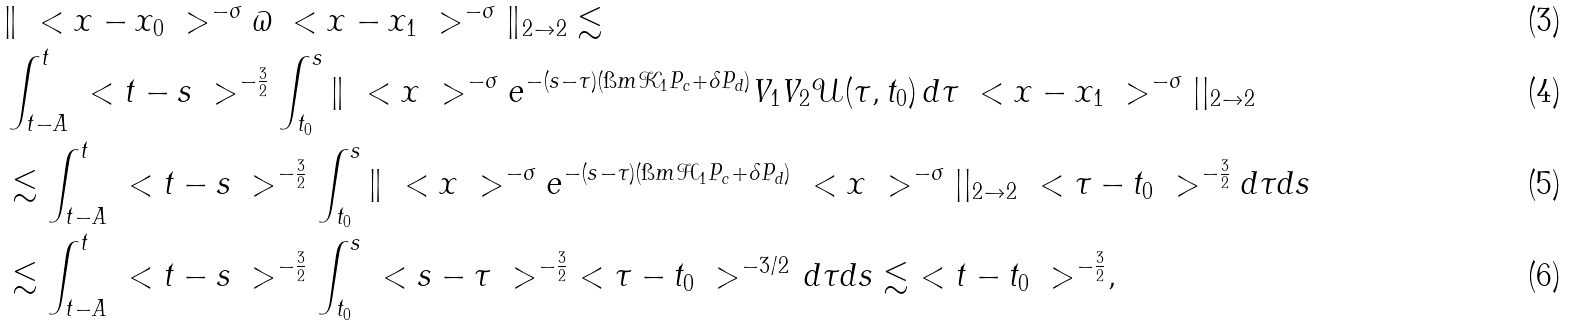Convert formula to latex. <formula><loc_0><loc_0><loc_500><loc_500>& \| \ < x - x _ { 0 } \ > ^ { - \sigma } \varpi \ < x - x _ { 1 } \ > ^ { - \sigma } \| _ { 2 \to 2 } \lesssim \\ & \int _ { t - A } ^ { t } \ < t - s \ > ^ { - \frac { 3 } { 2 } } \int _ { t _ { 0 } } ^ { s } \| \ < x \ > ^ { - \sigma } e ^ { - ( s - \tau ) ( \i m \mathcal { K } _ { 1 } P _ { c } + \delta P _ { d } ) } V _ { 1 } V _ { 2 } \mathcal { U } ( \tau , t _ { 0 } ) \, d \tau \ < x - x _ { 1 } \ > ^ { - \sigma } | | _ { 2 \to 2 } \\ & \lesssim \int _ { t - A } ^ { t } \ < t - s \ > ^ { - \frac { 3 } { 2 } } \int _ { t _ { 0 } } ^ { s } \| \ < x \ > ^ { - \sigma } e ^ { - ( s - \tau ) ( \i m \mathcal { H } _ { 1 } P _ { c } + \delta P _ { d } ) } \ < x \ > ^ { - \sigma } | | _ { 2 \to 2 } \ < \tau - t _ { 0 } \ > ^ { - \frac { 3 } { 2 } } d \tau d s \\ & \lesssim \int _ { t - A } ^ { t } \ < t - s \ > ^ { - \frac { 3 } { 2 } } \int _ { t _ { 0 } } ^ { s } \ < s - \tau \ > ^ { - \frac { 3 } { 2 } } \ < \tau - t _ { 0 } \ > ^ { - 3 / 2 } \, d \tau d s \lesssim \ < t - t _ { 0 } \ > ^ { - \frac { 3 } { 2 } } ,</formula> 